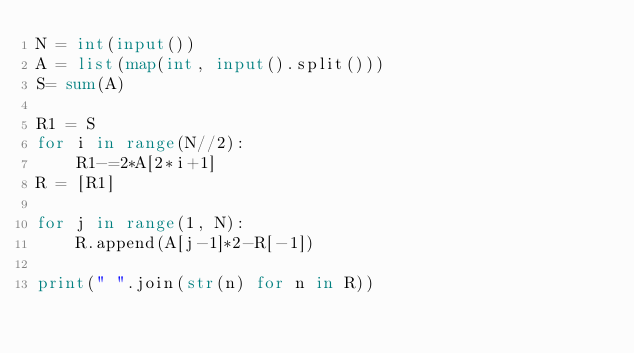<code> <loc_0><loc_0><loc_500><loc_500><_Python_>N = int(input())
A = list(map(int, input().split()))
S= sum(A)

R1 = S
for i in range(N//2):
    R1-=2*A[2*i+1]
R = [R1]

for j in range(1, N):
    R.append(A[j-1]*2-R[-1])

print(" ".join(str(n) for n in R))</code> 